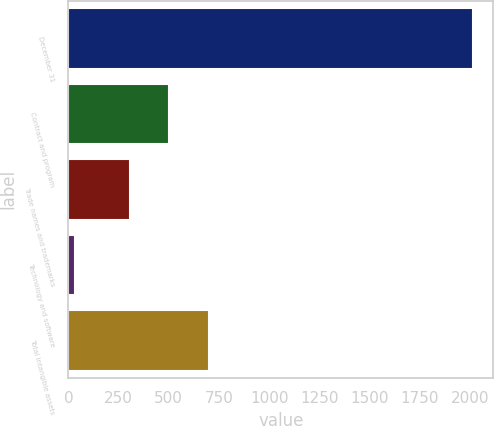<chart> <loc_0><loc_0><loc_500><loc_500><bar_chart><fcel>December 31<fcel>Contract and program<fcel>Trade names and trademarks<fcel>Technology and software<fcel>Total intangible assets<nl><fcel>2017<fcel>503.5<fcel>305<fcel>32<fcel>702<nl></chart> 